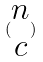Convert formula to latex. <formula><loc_0><loc_0><loc_500><loc_500>( \begin{matrix} n \\ c \end{matrix} )</formula> 